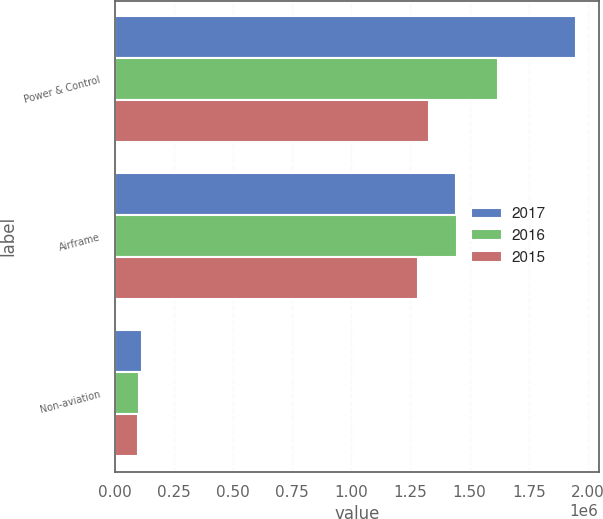Convert chart to OTSL. <chart><loc_0><loc_0><loc_500><loc_500><stacked_bar_chart><ecel><fcel>Power & Control<fcel>Airframe<fcel>Non-aviation<nl><fcel>2017<fcel>1.94817e+06<fcel>1.44207e+06<fcel>114047<nl><fcel>2016<fcel>1.62174e+06<fcel>1.44789e+06<fcel>101776<nl><fcel>2015<fcel>1.33014e+06<fcel>1.28071e+06<fcel>96274<nl></chart> 